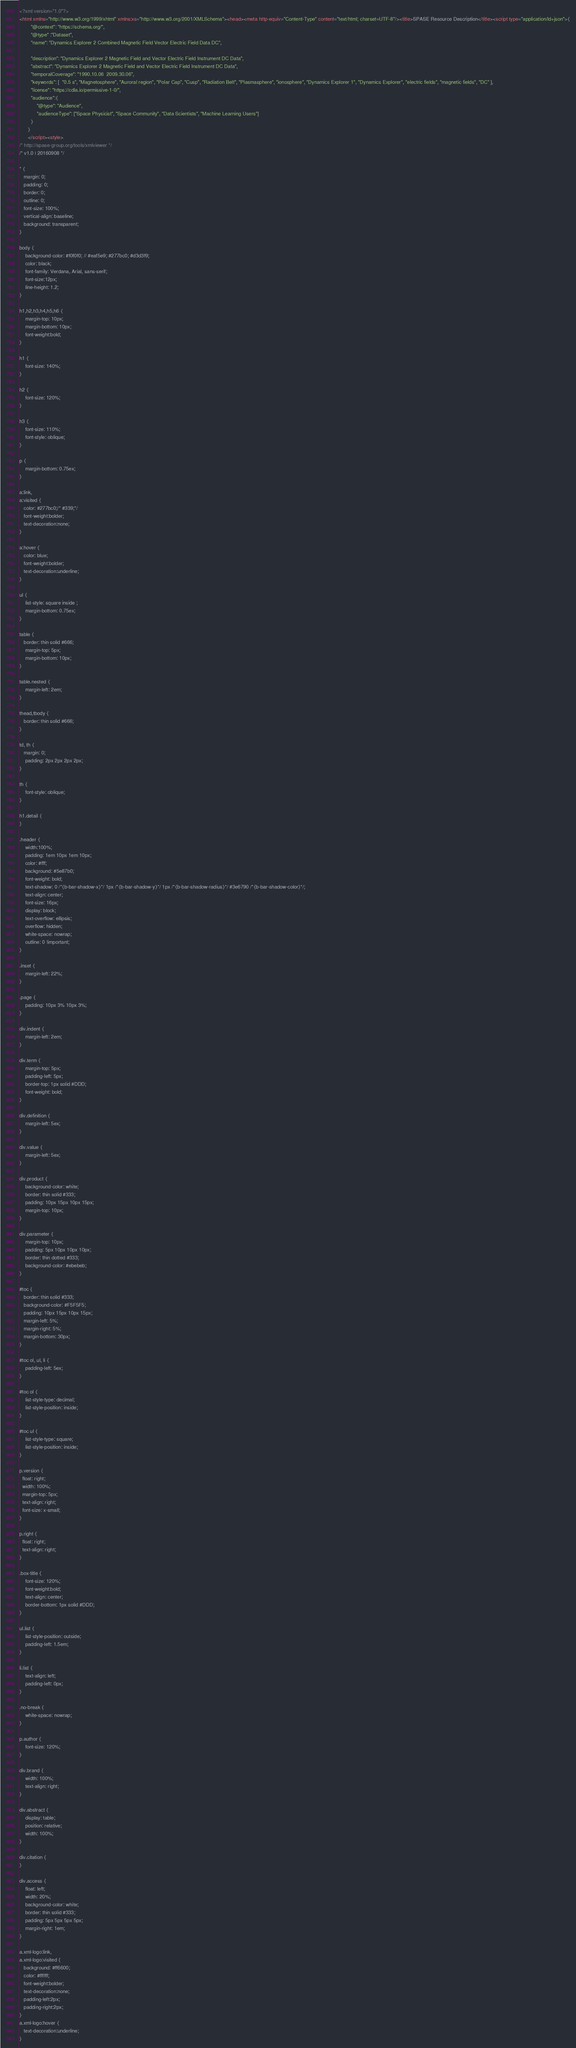Convert code to text. <code><loc_0><loc_0><loc_500><loc_500><_HTML_><?xml version="1.0"?>
<html xmlns="http://www.w3.org/1999/xhtml" xmlns:xs="http://www.w3.org/2001/XMLSchema"><head><meta http-equiv="Content-Type" content="text/html; charset=UTF-8"/><title>SPASE Resource Description</title><script type="application/ld+json">{
		"@context": "https://schema.org/",
		"@type" :"Dataset",
		"name": "Dynamics Explorer 2 Combined Magnetic Field Vector Electric Field Data DC",
     
 		"description": "Dynamics Explorer 2 Magnetic Field and Vector Electric Field Instrument DC Data",
		"abstract": "Dynamics Explorer 2 Magnetic Field and Vector Electric Field Instrument DC Data",
		"temporalCoverage": "1990.10.06  2009.30.06",
		"keywords": [  "0.5 s", "Magnetosphere", "Auroral region", "Polar Cap", "Cusp", "Radiation Belt", "Plasmasphere", "ionosphere", "Dynamics Explorer 1", "Dynamics Explorer", "electric fields", "magnetic fields", "DC" ],
		"license": "https://cdla.io/permissive-1-0/",
        "audience":{
            "@type": "Audience",
            "audienceType": ["Space Physicist", "Space Community", "Data Scientists", "Machine Learning Users"]
        }
	  }
	  </script><style>
/* http://spase-group.org/tools/xmlviewer */
/* v1.0 | 20160908 */

* {
   margin: 0;
   padding: 0;
   border: 0;
   outline: 0;
   font-size: 100%;
   vertical-align: baseline;
   background: transparent;
}

body {
	background-color: #f0f0f0; // #eaf5e9; #277bc0; #d3d3f9;
	color: black;
	font-family: Verdana, Arial, sans-serif; 
	font-size:12px; 
	line-height: 1.2;
}
 
h1,h2,h3,h4,h5,h6 {
	margin-top: 10px;
	margin-bottom: 10px;
	font-weight:bold;
}

h1 {
	font-size: 140%;
}

h2 {
	font-size: 120%;
}

h3 {
	font-size: 110%;
	font-style: oblique;
}

p {
	margin-bottom: 0.75ex;
}

a:link,
a:visited {
   color: #277bc0;/* #339;*/
   font-weight:bolder; 
   text-decoration:none; 
}

a:hover {
   color: blue;
   font-weight:bolder; 
   text-decoration:underline; 
}

ul {
	list-style: square inside ;
	margin-bottom: 0.75ex;
}

table {
   border: thin solid #666;
	margin-top: 5px;
	margin-bottom: 10px;
}

table.nested {
	margin-left: 2em;
}

thead,tbody {
   border: thin solid #666;
}

td, th {
   margin: 0;
	padding: 2px 2px 2px 2px;
}

th {
	font-style: oblique;
}

h1.detail {
}

.header {
	width:100%;
	padding: 1em 10px 1em 10px;
	color: #fff;
	background: #5e87b0;
	font-weight: bold;
	text-shadow: 0 /*{b-bar-shadow-x}*/ 1px /*{b-bar-shadow-y}*/ 1px /*{b-bar-shadow-radius}*/ #3e6790 /*{b-bar-shadow-color}*/;
	text-align: center;
	font-size: 16px;
	display: block;
	text-overflow: ellipsis;
	overflow: hidden;
	white-space: nowrap;
	outline: 0 !important;
}

.inset {
	margin-left: 22%;
}

.page {
	padding: 10px 3% 10px 3%;
}

div.indent {
    margin-left: 2em;
}

div.term {
	margin-top: 5px;
	padding-left: 5px;
	border-top: 1px solid #DDD;
	font-weight: bold;
}

div.definition {
	margin-left: 5ex;
}

div.value {
	margin-left: 5ex;
}

div.product {
	background-color: white;
	border: thin solid #333;
	padding: 10px 15px 10px 15px;
	margin-top: 10px;
}

div.parameter {
	margin-top: 10px;
	padding: 5px 10px 10px 10px;
	border: thin dotted #333;
	background-color: #ebebeb;
}

#toc {
   border: thin solid #333;
   background-color: #F5F5F5; 
   padding: 10px 15px 10px 15px;
   margin-left: 5%;
   margin-right: 5%;
   margin-bottom: 30px;
}

#toc ol, ul, li {
	padding-left: 5ex;
}

#toc ol {
	list-style-type: decimal;
	list-style-position: inside; 
}

#toc ul {
	list-style-type: square;
	list-style-position: inside; 
}

p.version {
  float: right;
  width: 100%;
  margin-top: 5px;
  text-align: right;
  font-size: x-small;
}

p.right {
  float: right;
  text-align: right;
}

.box-title {
	font-size: 120%;
	font-weight:bold;
	text-align: center;
	border-bottom: 1px solid #DDD;
}

ul.list {
	list-style-position: outside;
	padding-left: 1.5em;
}

li.list {
	text-align: left;
	padding-left: 0px;
}

.no-break {
	white-space: nowrap;
}

p.author {
	font-size: 120%;
}

div.brand {
	width: 100%;
	text-align: right;
}

div.abstract {
	display: table;
	position: relative;
	width: 100%;
}

div.citation {
}

div.access {
	float: left;
	width: 20%;
	background-color: white;
	border: thin solid #333;
	padding: 5px 5px 5px 5px;
	margin-right: 1em;
}

a.xml-logo:link,
a.xml-logo:visited {
   background: #ff6600;
   color: #ffffff;
   font-weight:bolder; 
   text-decoration:none; 
   padding-left:2px;
   padding-right:2px;
}
a.xml-logo:hover {
   text-decoration:underline; 
}
</code> 